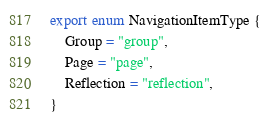Convert code to text. <code><loc_0><loc_0><loc_500><loc_500><_TypeScript_>export enum NavigationItemType {
	Group = "group",
	Page = "page",
	Reflection = "reflection",
}</code> 